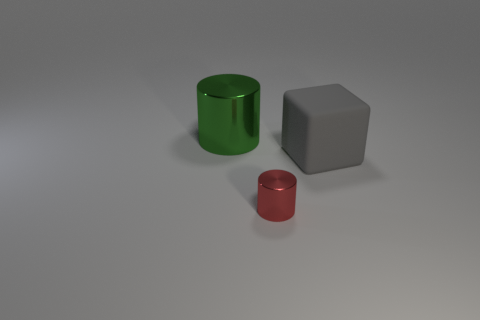How many objects are to the left of the large gray object and behind the small red thing?
Provide a short and direct response. 1. Are there any other things that have the same color as the big metallic cylinder?
Ensure brevity in your answer.  No. What number of rubber things are tiny cylinders or big cylinders?
Your answer should be compact. 0. The large object that is on the right side of the shiny thing that is in front of the large thing behind the large block is made of what material?
Your response must be concise. Rubber. There is a big thing that is on the right side of the metallic cylinder in front of the large green cylinder; what is its material?
Give a very brief answer. Rubber. There is a cylinder behind the gray rubber thing; does it have the same size as the gray matte thing right of the red object?
Your answer should be compact. Yes. Is there anything else that has the same material as the big cube?
Make the answer very short. No. What number of tiny objects are rubber things or purple matte cylinders?
Make the answer very short. 0. How many things are things that are on the right side of the green metallic thing or large metal things?
Offer a very short reply. 3. What number of other objects are there of the same shape as the red thing?
Provide a succinct answer. 1. 